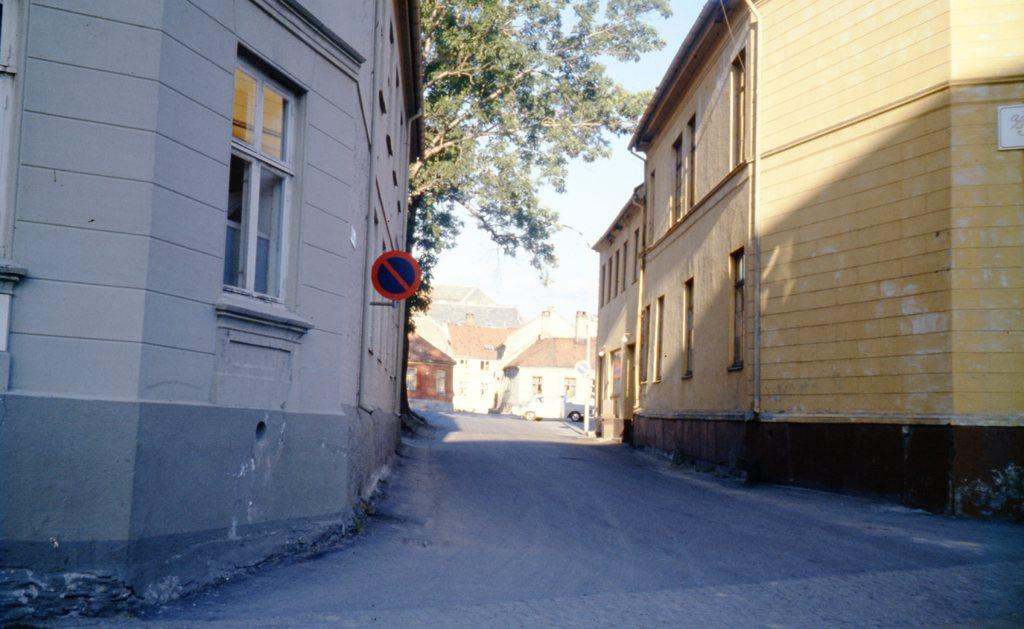What type of structures can be seen in the image? There are buildings in the image. What is located in the middle of the image? There is a tree in the middle of the image. What mode of transportation is visible in the image? There is a car in the image. What is visible at the top of the image? The sky is visible at the top of the image. What can be used for displaying information in the image? There is a sign board in the image. What type of nerve can be seen in the image? There is no nerve present in the image; it features buildings, a tree, a car, a sign board, and the sky. What show is being performed in the image? There is no show being performed in the image; it is a scene with buildings, a tree, a car, a sign board, and the sky. 